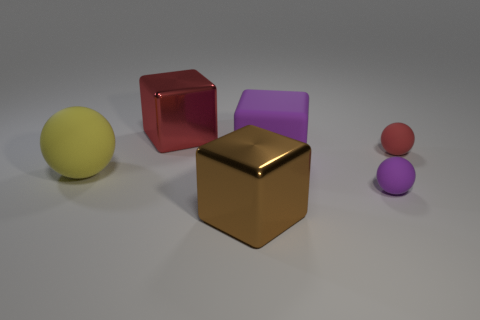Subtract all large brown metal cubes. How many cubes are left? 2 Add 4 red metal things. How many objects exist? 10 Subtract 0 brown cylinders. How many objects are left? 6 Subtract 2 spheres. How many spheres are left? 1 Subtract all green balls. Subtract all cyan blocks. How many balls are left? 3 Subtract all green cylinders. How many red spheres are left? 1 Subtract all brown metal cylinders. Subtract all rubber things. How many objects are left? 2 Add 4 blocks. How many blocks are left? 7 Add 4 large purple cubes. How many large purple cubes exist? 5 